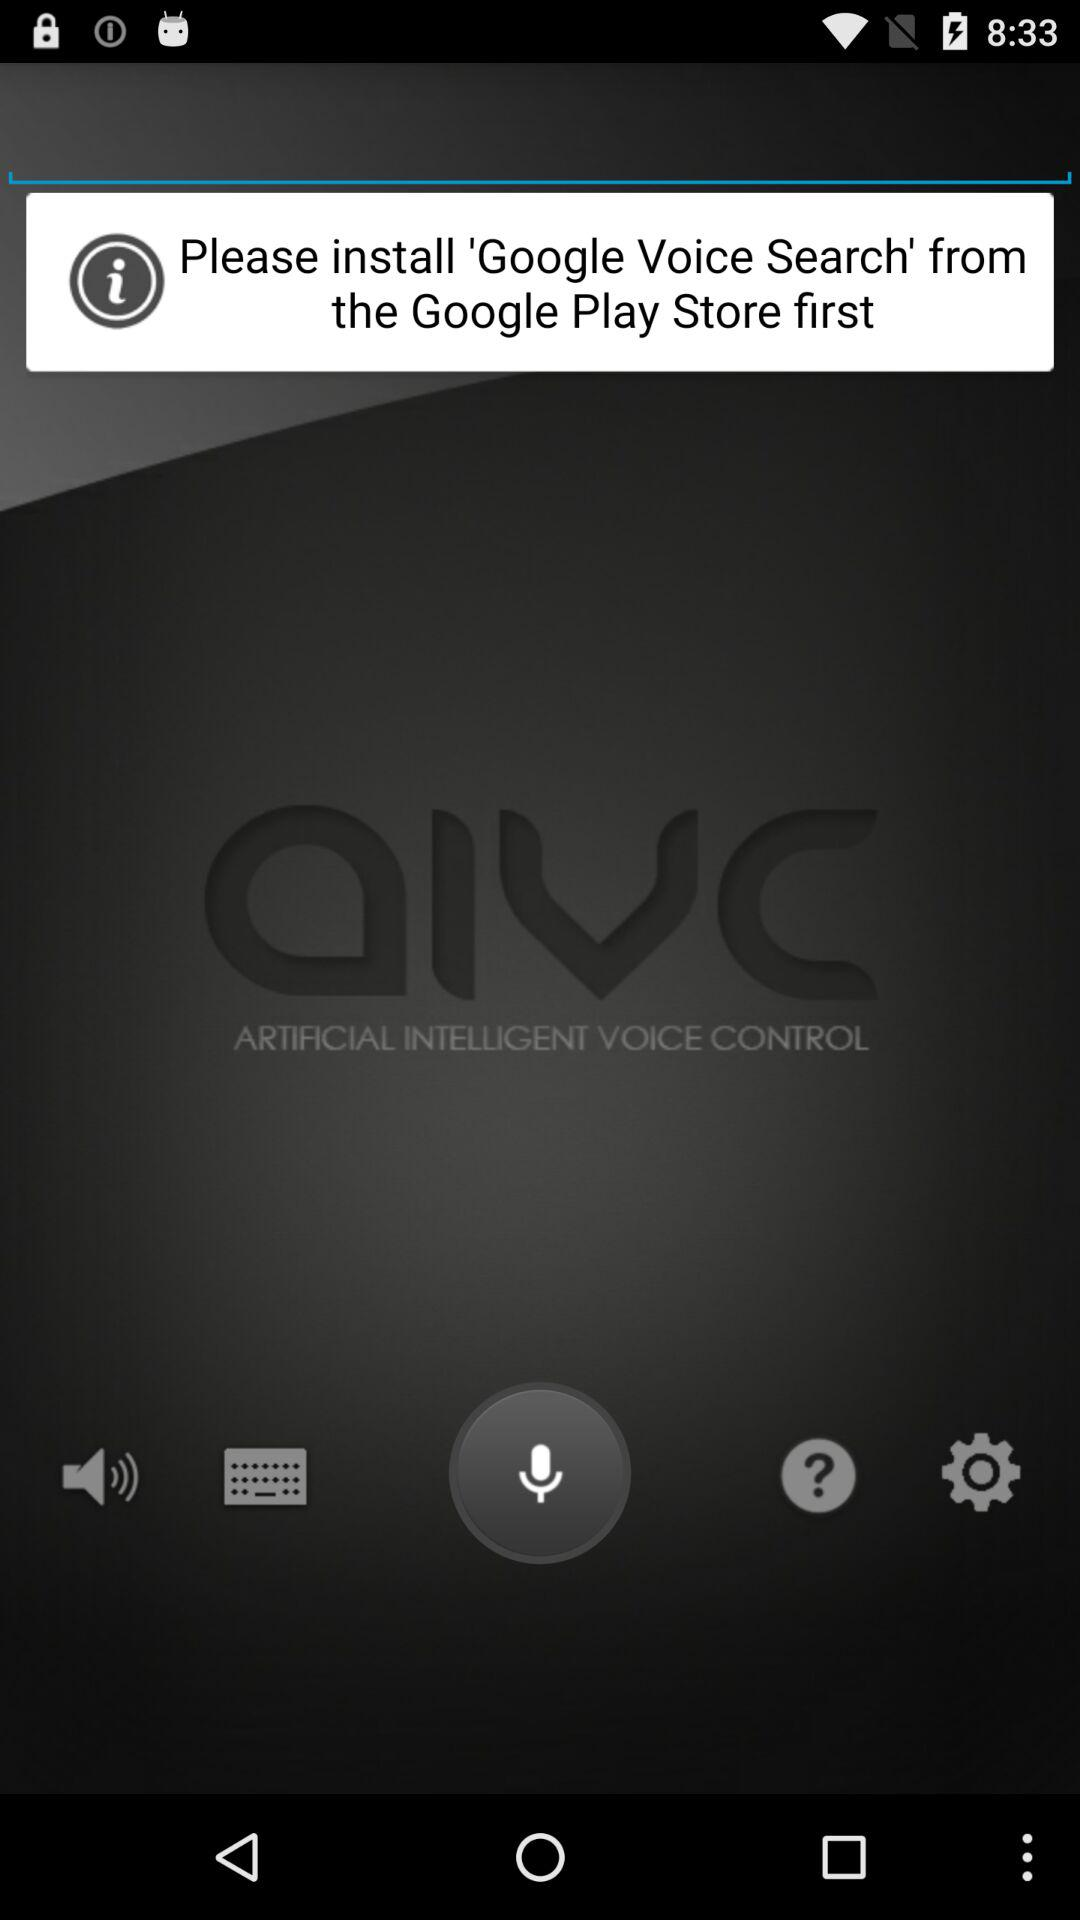From where we can install Google voice search? We can install Google Voice Search from the Google Play Store. 